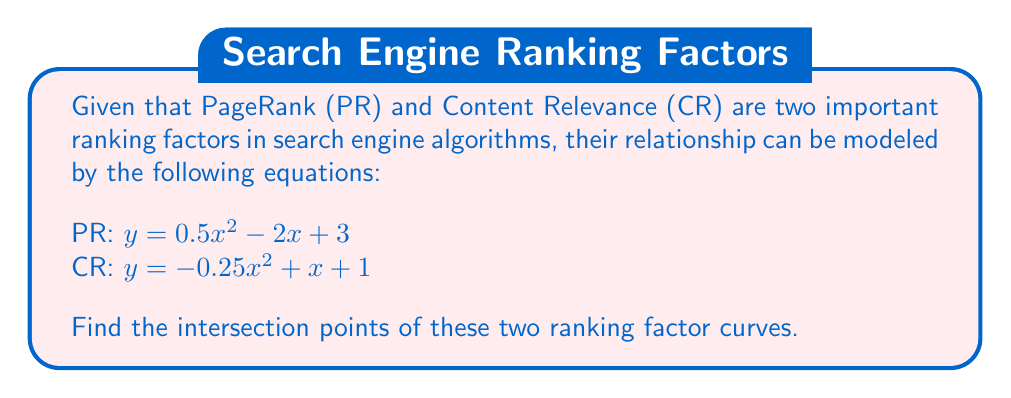Give your solution to this math problem. To find the intersection points, we need to solve the equation where PR equals CR:

1) Set the equations equal to each other:
   $0.5x^2 - 2x + 3 = -0.25x^2 + x + 1$

2) Rearrange the equation to standard form:
   $0.5x^2 - 2x + 3 + 0.25x^2 - x - 1 = 0$
   $0.75x^2 - 3x + 2 = 0$

3) Multiply all terms by 4 to eliminate fractions:
   $3x^2 - 12x + 8 = 0$

4) This is a quadratic equation. We can solve it using the quadratic formula:
   $x = \frac{-b \pm \sqrt{b^2 - 4ac}}{2a}$

   Where $a = 3$, $b = -12$, and $c = 8$

5) Substituting these values:
   $x = \frac{12 \pm \sqrt{(-12)^2 - 4(3)(8)}}{2(3)}$
   $x = \frac{12 \pm \sqrt{144 - 96}}{6}$
   $x = \frac{12 \pm \sqrt{48}}{6}$
   $x = \frac{12 \pm 4\sqrt{3}}{6}$

6) Simplifying:
   $x = 2 \pm \frac{2\sqrt{3}}{3}$

7) This gives us two solutions:
   $x_1 = 2 + \frac{2\sqrt{3}}{3} \approx 3.15$
   $x_2 = 2 - \frac{2\sqrt{3}}{3} \approx 0.85$

8) To find the y-coordinates, substitute these x-values into either of the original equations. Let's use the PR equation:

   For $x_1$: $y = 0.5(3.15)^2 - 2(3.15) + 3 \approx 1.58$
   For $x_2$: $y = 0.5(0.85)^2 - 2(0.85) + 3 \approx 1.58$

Therefore, the intersection points are approximately (3.15, 1.58) and (0.85, 1.58).
Answer: $(2 + \frac{2\sqrt{3}}{3}, \frac{7}{4})$ and $(2 - \frac{2\sqrt{3}}{3}, \frac{7}{4})$ 